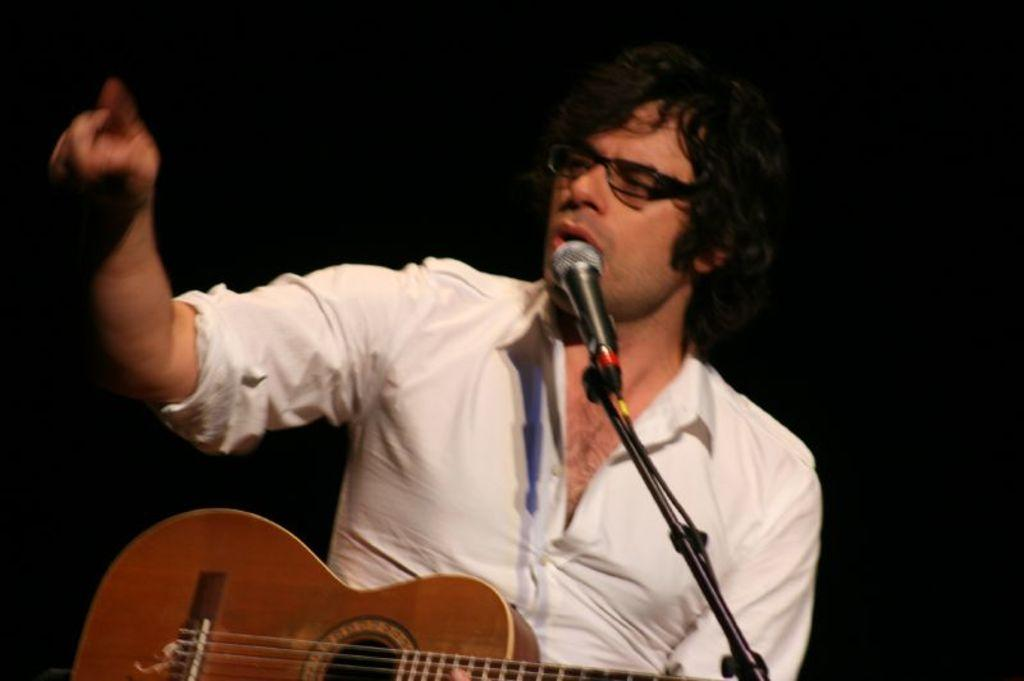Who or what is the main subject of the image? There is a person in the image. What is the person holding in the image? The person is holding a guitar. What object is in front of the person? There is a microphone in front of the person. What activity is the person engaged in? The person appears to be singing. What type of cord is wrapped around the person's neck in the image? There is no cord wrapped around the person's neck in the image. What type of prose is being recited by the person in the image? The person is singing, not reciting prose, in the image. 